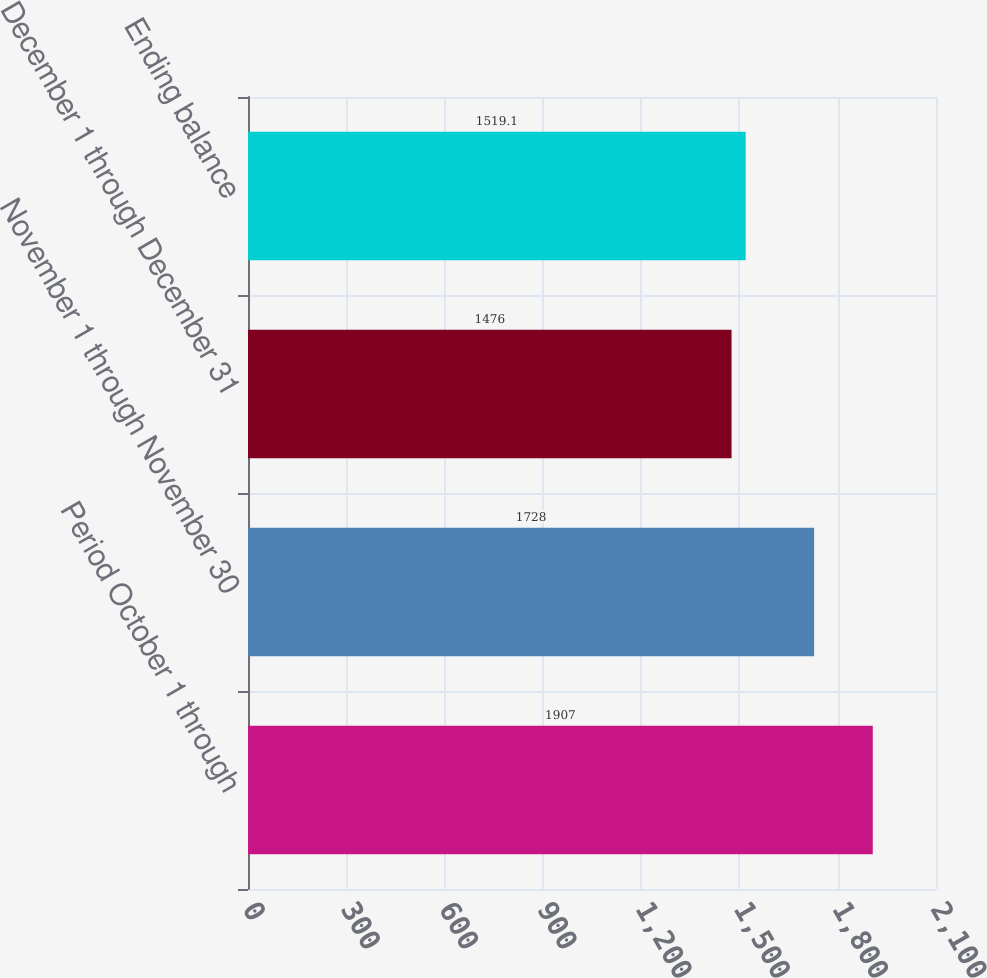Convert chart. <chart><loc_0><loc_0><loc_500><loc_500><bar_chart><fcel>Period October 1 through<fcel>November 1 through November 30<fcel>December 1 through December 31<fcel>Ending balance<nl><fcel>1907<fcel>1728<fcel>1476<fcel>1519.1<nl></chart> 